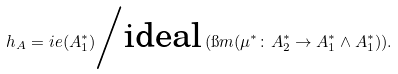Convert formula to latex. <formula><loc_0><loc_0><loc_500><loc_500>\ h _ { A } = \L i e ( A _ { 1 } ^ { * } ) \Big \slash \text {ideal} \, ( \i m ( \mu ^ { * } \colon A _ { 2 } ^ { * } \to A _ { 1 } ^ { * } \wedge A _ { 1 } ^ { * } ) ) \Big . .</formula> 